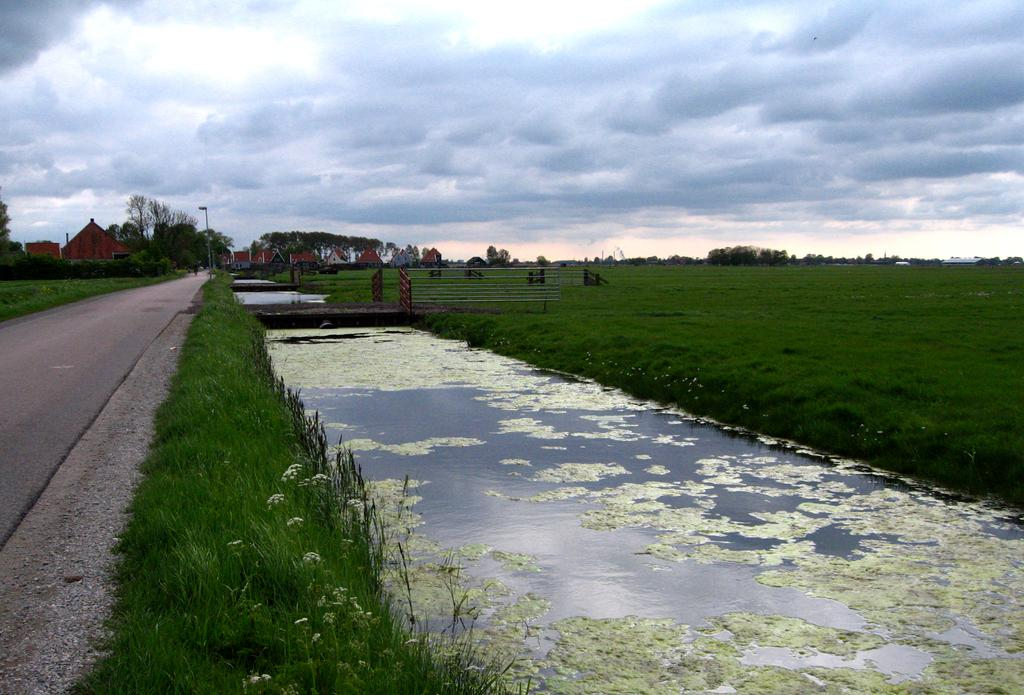What is the main feature in the center of the image? There is water in the center of the image. What type of vegetation can be seen on the right side of the image? There is grass on the ground on the right side of the image. What can be seen in the background of the image? There are trees and buildings in the background of the image. How would you describe the sky in the image? The sky is cloudy in the image. Can you tell me how many eggs are in the eggnog in the image? There is no eggnog or eggs present in the image. What type of guitar is being played in the background of the image? There is no guitar or music-related activity depicted in the image. 